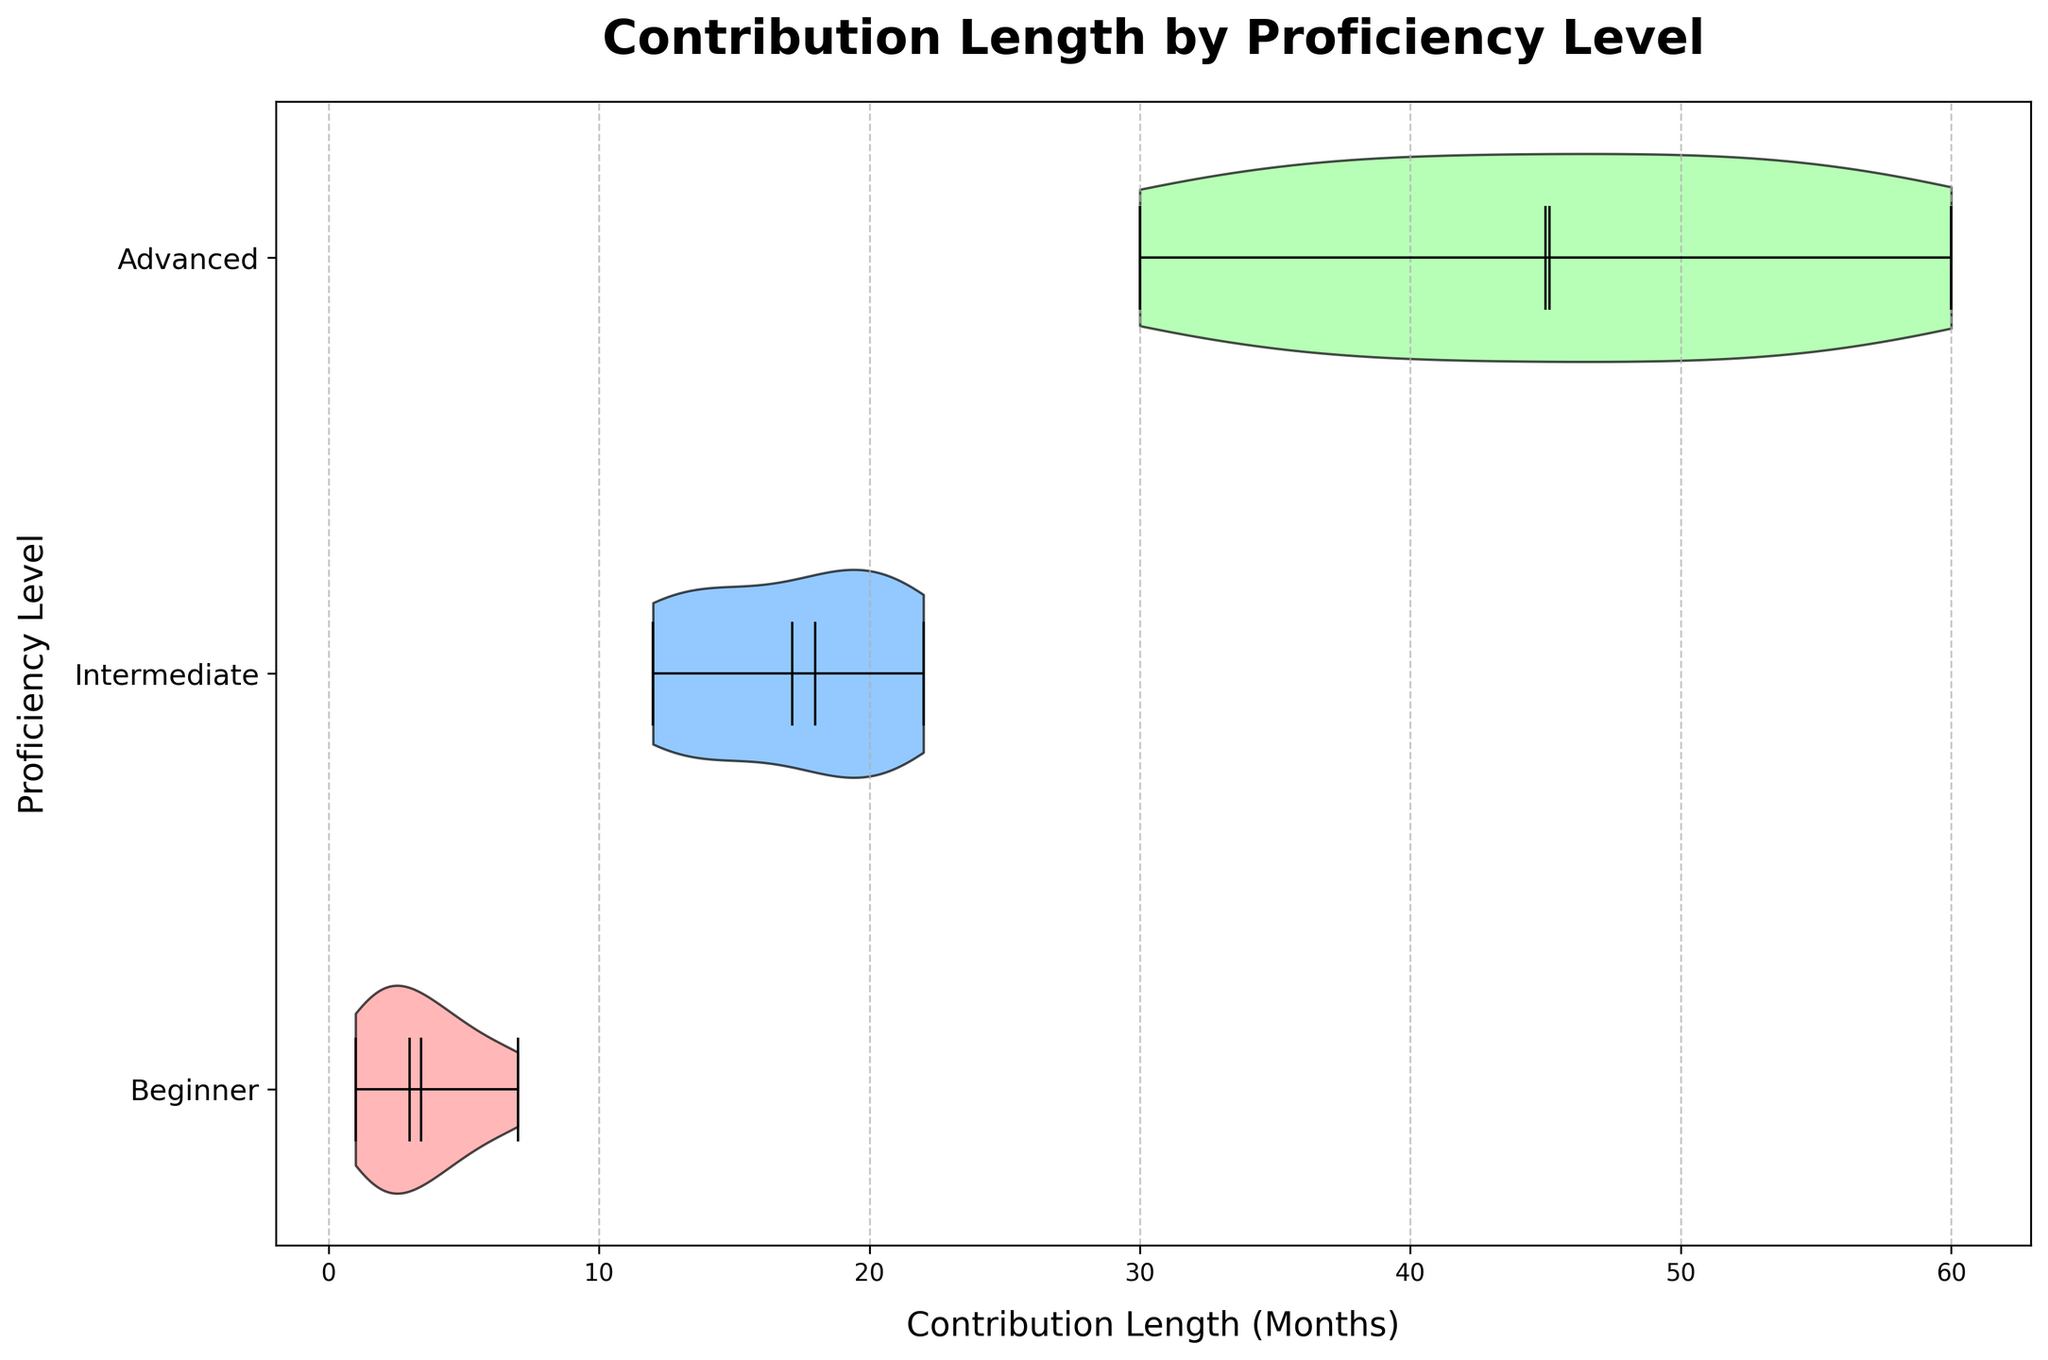What's the title of the plot? The title is usually displayed at the top center of the figure. Here, it is visible as "Contribution Length by Proficiency Level".
Answer: Contribution Length by Proficiency Level What are the labels on the axes? The x-axis label is displayed horizontally at the bottom and reads "Contribution Length (Months)". The y-axis label is displayed vertically on the left and reads "Proficiency Level".
Answer: Contribution Length (Months) and Proficiency Level How many proficiency levels are shown in the plot? The y-axis indicates the categories, which in this case are three: "Beginner", "Intermediate", and "Advanced".
Answer: 3 What color represents the "Advanced" proficiency level? The colors of the violins are different for each proficiency level. The "Advanced" proficiency level is represented by a light green color.
Answer: Light green What is the approximate range of contribution lengths for the "Beginner" proficiency level? The width of the violin plot for the "Beginner" level spans from near 0 up to around 7 months on the x-axis.
Answer: 0 to 7 months What proficiency level has the widest range of contribution lengths? Viewing the different spans of the violins, the "Advanced" proficiency level shows points from around 30 to 60 months, which is the widest range compared to other levels.
Answer: Advanced Which proficiency level has the highest mean contribution length? The mean values are depicted by the white dots on the violins. The "Advanced" proficiency level shows the highest mean, positioned farthest to the right on the x-axis.
Answer: Advanced How does the median contribution length of "Intermediate" compare to "Beginner"? The median values are indicated by a horizontal black bar in the violins. "Intermediate" has its median further right on the x-axis compared to "Beginner", indicating higher median contribution lengths.
Answer: Intermediate has a higher median Is the median contribution length of "Advanced" closer to the mean or the minimum of its distribution? The median bar for "Advanced" is near the center of its violin, which is closer to the mean (white dot) than the extending minimum (lower end line).
Answer: Closer to the mean Comparing all proficiency levels, which one has the most concentrated distribution of contribution lengths? The violin plot width indicates distribution concentration. The "Beginner" proficiency level shows a relatively narrow width, indicating a more concentrated distribution of contribution lengths.
Answer: Beginner 